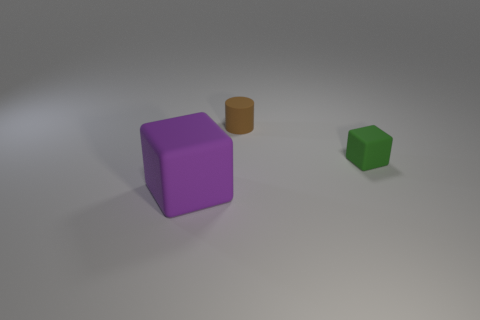Considering their size, what might these objects be used for in a real-world setting? Given their simplistic shape and uniform color, these objects could be used as teaching aids in a classroom to help students understand geometric concepts or for a designer to visualize spatial arrangements in a scaled model. Alternatively, these could be basic elements in a graphic design or animation project. 